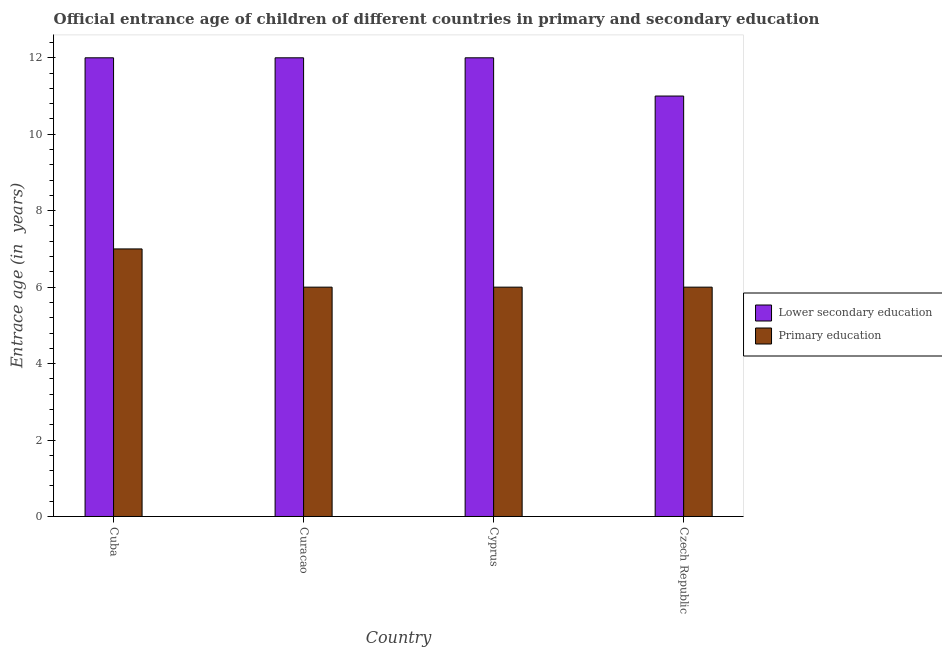Are the number of bars on each tick of the X-axis equal?
Ensure brevity in your answer.  Yes. How many bars are there on the 4th tick from the left?
Ensure brevity in your answer.  2. How many bars are there on the 2nd tick from the right?
Ensure brevity in your answer.  2. What is the label of the 2nd group of bars from the left?
Your response must be concise. Curacao. In how many cases, is the number of bars for a given country not equal to the number of legend labels?
Provide a short and direct response. 0. What is the entrance age of chiildren in primary education in Cuba?
Offer a very short reply. 7. Across all countries, what is the maximum entrance age of chiildren in primary education?
Give a very brief answer. 7. Across all countries, what is the minimum entrance age of children in lower secondary education?
Give a very brief answer. 11. In which country was the entrance age of chiildren in primary education maximum?
Provide a short and direct response. Cuba. In which country was the entrance age of children in lower secondary education minimum?
Your answer should be compact. Czech Republic. What is the total entrance age of children in lower secondary education in the graph?
Provide a succinct answer. 47. What is the difference between the entrance age of children in lower secondary education in Cuba and that in Czech Republic?
Your response must be concise. 1. What is the difference between the entrance age of chiildren in primary education in Cuba and the entrance age of children in lower secondary education in Cyprus?
Provide a succinct answer. -5. What is the average entrance age of chiildren in primary education per country?
Provide a short and direct response. 6.25. What is the difference between the entrance age of chiildren in primary education and entrance age of children in lower secondary education in Czech Republic?
Keep it short and to the point. -5. What is the ratio of the entrance age of children in lower secondary education in Cyprus to that in Czech Republic?
Your answer should be compact. 1.09. What is the difference between the highest and the lowest entrance age of chiildren in primary education?
Offer a terse response. 1. Is the sum of the entrance age of children in lower secondary education in Curacao and Czech Republic greater than the maximum entrance age of chiildren in primary education across all countries?
Provide a short and direct response. Yes. What does the 2nd bar from the left in Cuba represents?
Provide a succinct answer. Primary education. What does the 2nd bar from the right in Cuba represents?
Provide a short and direct response. Lower secondary education. How many bars are there?
Ensure brevity in your answer.  8. Are all the bars in the graph horizontal?
Make the answer very short. No. Are the values on the major ticks of Y-axis written in scientific E-notation?
Give a very brief answer. No. How many legend labels are there?
Provide a short and direct response. 2. What is the title of the graph?
Make the answer very short. Official entrance age of children of different countries in primary and secondary education. What is the label or title of the Y-axis?
Your response must be concise. Entrace age (in  years). What is the Entrace age (in  years) in Lower secondary education in Czech Republic?
Offer a terse response. 11. What is the Entrace age (in  years) of Primary education in Czech Republic?
Ensure brevity in your answer.  6. Across all countries, what is the minimum Entrace age (in  years) in Lower secondary education?
Provide a short and direct response. 11. What is the total Entrace age (in  years) in Lower secondary education in the graph?
Provide a succinct answer. 47. What is the total Entrace age (in  years) in Primary education in the graph?
Ensure brevity in your answer.  25. What is the difference between the Entrace age (in  years) of Lower secondary education in Cuba and that in Cyprus?
Offer a terse response. 0. What is the difference between the Entrace age (in  years) in Primary education in Cuba and that in Czech Republic?
Offer a terse response. 1. What is the difference between the Entrace age (in  years) of Lower secondary education in Curacao and that in Cyprus?
Your response must be concise. 0. What is the difference between the Entrace age (in  years) in Primary education in Curacao and that in Czech Republic?
Give a very brief answer. 0. What is the difference between the Entrace age (in  years) in Primary education in Cyprus and that in Czech Republic?
Your response must be concise. 0. What is the difference between the Entrace age (in  years) in Lower secondary education in Cuba and the Entrace age (in  years) in Primary education in Czech Republic?
Make the answer very short. 6. What is the difference between the Entrace age (in  years) in Lower secondary education in Curacao and the Entrace age (in  years) in Primary education in Cyprus?
Provide a short and direct response. 6. What is the difference between the Entrace age (in  years) of Lower secondary education in Curacao and the Entrace age (in  years) of Primary education in Czech Republic?
Offer a terse response. 6. What is the difference between the Entrace age (in  years) in Lower secondary education in Cyprus and the Entrace age (in  years) in Primary education in Czech Republic?
Provide a succinct answer. 6. What is the average Entrace age (in  years) of Lower secondary education per country?
Offer a terse response. 11.75. What is the average Entrace age (in  years) in Primary education per country?
Your answer should be very brief. 6.25. What is the difference between the Entrace age (in  years) of Lower secondary education and Entrace age (in  years) of Primary education in Cuba?
Keep it short and to the point. 5. What is the difference between the Entrace age (in  years) of Lower secondary education and Entrace age (in  years) of Primary education in Curacao?
Make the answer very short. 6. What is the difference between the Entrace age (in  years) in Lower secondary education and Entrace age (in  years) in Primary education in Cyprus?
Offer a terse response. 6. What is the ratio of the Entrace age (in  years) of Lower secondary education in Cuba to that in Curacao?
Your answer should be compact. 1. What is the ratio of the Entrace age (in  years) of Lower secondary education in Curacao to that in Czech Republic?
Provide a succinct answer. 1.09. What is the ratio of the Entrace age (in  years) of Lower secondary education in Cyprus to that in Czech Republic?
Your answer should be compact. 1.09. What is the difference between the highest and the second highest Entrace age (in  years) in Primary education?
Provide a succinct answer. 1. 